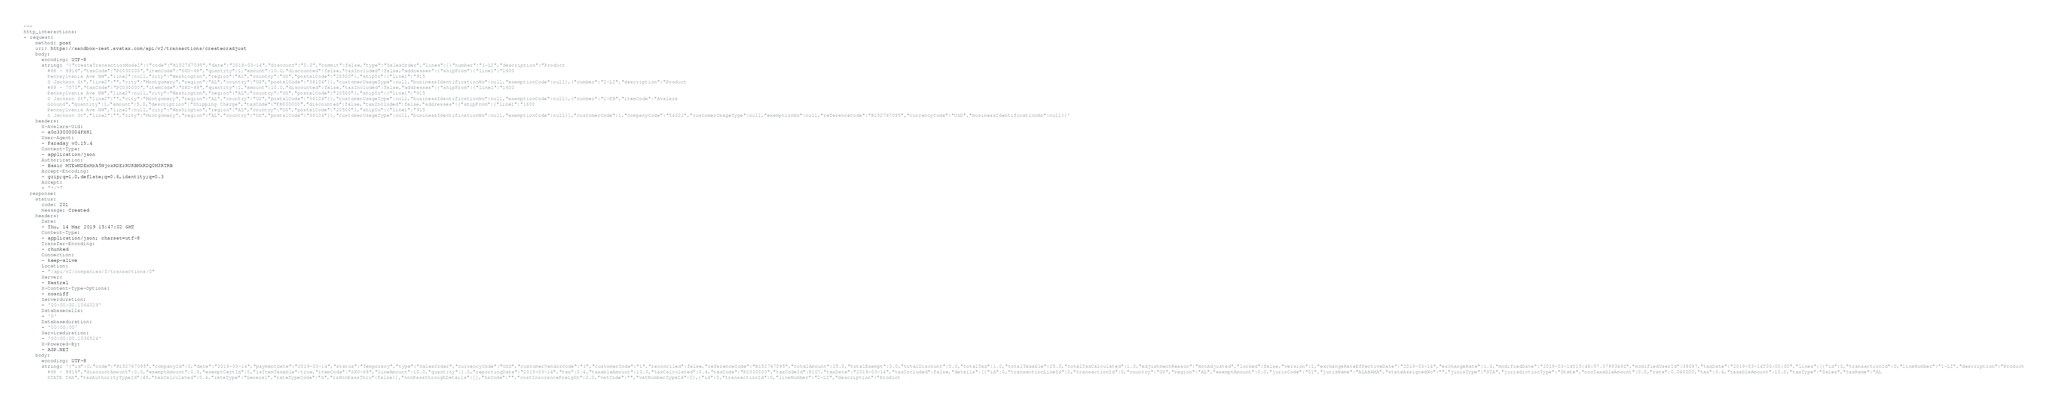Convert code to text. <code><loc_0><loc_0><loc_500><loc_500><_YAML_>---
http_interactions:
- request:
    method: post
    uri: https://sandbox-rest.avatax.com/api/v2/transactions/createoradjust
    body:
      encoding: UTF-8
      string: '{"createTransactionModel":{"code":"R152767095","date":"2019-03-14","discount":"0.0","commit":false,"type":"SalesOrder","lines":[{"number":"1-LI","description":"Product
        #68 - 8816","taxCode":"PC030000","itemCode":"SKU-68","quantity":1,"amount":10.0,"discounted":false,"taxIncluded":false,"addresses":{"shipFrom":{"line1":"1600
        Pennsylvania Ave NW","line2":null,"city":"Washington","region":"AL","country":"US","postalCode":"20500"},"shipTo":{"line1":"915
        S Jackson St","line2":"","city":"Montgomery","region":"AL","country":"US","postalCode":"36104"}},"customerUsageType":null,"businessIdentificationNo":null,"exemptionCode":null},{"number":"2-LI","description":"Product
        #69 - 7570","taxCode":"PC030000","itemCode":"SKU-69","quantity":1,"amount":10.0,"discounted":false,"taxIncluded":false,"addresses":{"shipFrom":{"line1":"1600
        Pennsylvania Ave NW","line2":null,"city":"Washington","region":"AL","country":"US","postalCode":"20500"},"shipTo":{"line1":"915
        S Jackson St","line2":"","city":"Montgomery","region":"AL","country":"US","postalCode":"36104"}},"customerUsageType":null,"businessIdentificationNo":null,"exemptionCode":null},{"number":"1-FR","itemCode":"Avalara
        Ground","quantity":1,"amount":5.0,"description":"Shipping Charge","taxCode":"FR000000","discounted":false,"taxIncluded":false,"addresses":{"shipFrom":{"line1":"1600
        Pennsylvania Ave NW","line2":null,"city":"Washington","region":"AL","country":"US","postalCode":"20500"},"shipTo":{"line1":"915
        S Jackson St","line2":"","city":"Montgomery","region":"AL","country":"US","postalCode":"36104"}},"customerUsageType":null,"businessIdentificationNo":null,"exemptionCode":null}],"customerCode":1,"companyCode":"54321","customerUsageType":null,"exemptionNo":null,"referenceCode":"R152767095","currencyCode":"USD","businessIdentificationNo":null}}'
    headers:
      X-Avalara-Uid:
      - a0o33000004FH8l
      User-Agent:
      - Faraday v0.15.4
      Content-Type:
      - application/json
      Authorization:
      - Basic MTEwMDExMzA5NjoxRDEzRURBMkRDQ0M3RTRB
      Accept-Encoding:
      - gzip;q=1.0,deflate;q=0.6,identity;q=0.3
      Accept:
      - "*/*"
  response:
    status:
      code: 201
      message: Created
    headers:
      Date:
      - Thu, 14 Mar 2019 15:47:02 GMT
      Content-Type:
      - application/json; charset=utf-8
      Transfer-Encoding:
      - chunked
      Connection:
      - keep-alive
      Location:
      - "/api/v2/companies/0/transactions/0"
      Server:
      - Kestrel
      X-Content-Type-Options:
      - nosniff
      Serverduration:
      - '00:00:00.1064029'
      Databasecalls:
      - '0'
      Databaseduration:
      - '00:00:00'
      Serviceduration:
      - '00:00:00.1036524'
      X-Powered-By:
      - ASP.NET
    body:
      encoding: UTF-8
      string: '{"id":0,"code":"R152767095","companyId":0,"date":"2019-03-14","paymentDate":"2019-03-14","status":"Temporary","type":"SalesOrder","currencyCode":"USD","customerVendorCode":"1","customerCode":"1","reconciled":false,"referenceCode":"R152767095","totalAmount":25.0,"totalExempt":0.0,"totalDiscount":0.0,"totalTax":1.0,"totalTaxable":25.0,"totalTaxCalculated":1.0,"adjustmentReason":"NotAdjusted","locked":false,"version":1,"exchangeRateEffectiveDate":"2019-03-14","exchangeRate":1.0,"modifiedDate":"2019-03-14T15:46:57.3789349Z","modifiedUserId":38097,"taxDate":"2019-03-14T00:00:00","lines":[{"id":0,"transactionId":0,"lineNumber":"1-LI","description":"Product
        #68 - 8816","discountAmount":0.0,"exemptAmount":0.0,"exemptCertId":0,"isItemTaxable":true,"itemCode":"SKU-68","lineAmount":10.0,"quantity":1.0,"reportingDate":"2019-03-14","tax":0.4,"taxableAmount":10.0,"taxCalculated":0.4,"taxCode":"PC030000","taxCodeId":8107,"taxDate":"2019-03-14","taxIncluded":false,"details":[{"id":0,"transactionLineId":0,"transactionId":0,"country":"US","region":"AL","exemptAmount":0.0,"jurisCode":"01","jurisName":"ALABAMA","stateAssignedNo":"","jurisType":"STA","jurisdictionType":"State","nonTaxableAmount":0.0,"rate":0.040000,"tax":0.4,"taxableAmount":10.0,"taxType":"Sales","taxName":"AL
        STATE TAX","taxAuthorityTypeId":45,"taxCalculated":0.4,"rateType":"General","rateTypeCode":"G","isNonPassThru":false}],"nonPassthroughDetails":[],"hsCode":"","costInsuranceFreight":0.0,"vatCode":"","vatNumberTypeId":0},{"id":0,"transactionId":0,"lineNumber":"2-LI","description":"Product</code> 